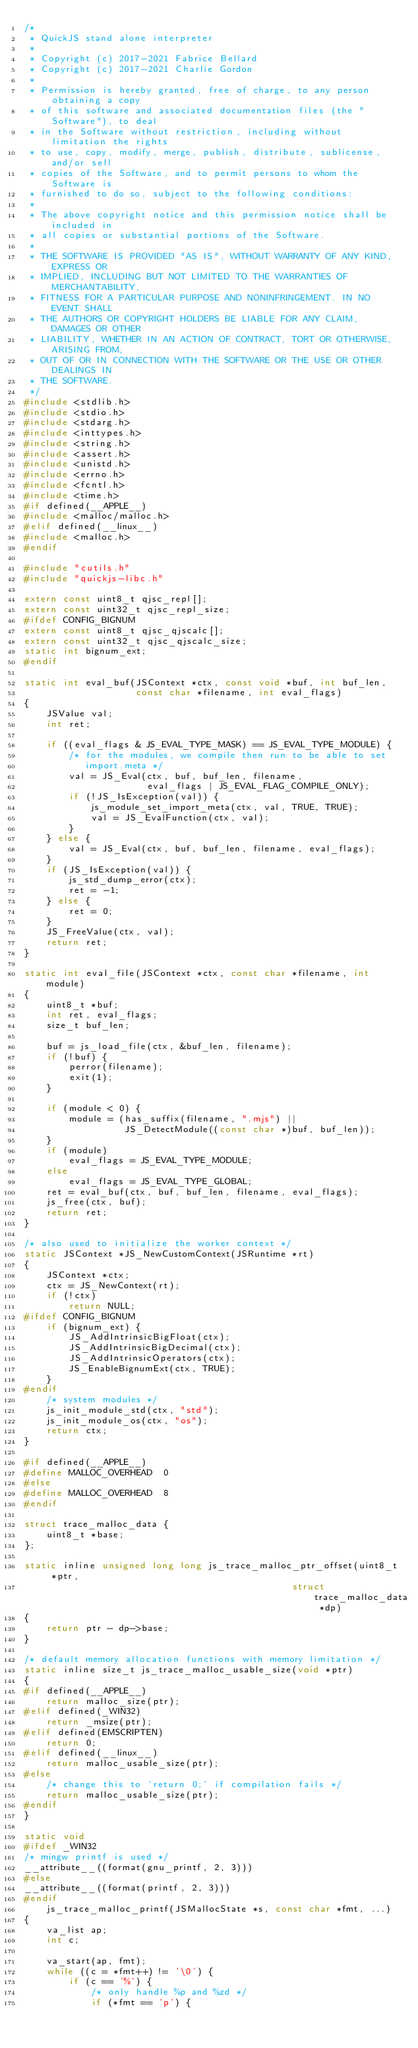Convert code to text. <code><loc_0><loc_0><loc_500><loc_500><_C_>/*
 * QuickJS stand alone interpreter
 * 
 * Copyright (c) 2017-2021 Fabrice Bellard
 * Copyright (c) 2017-2021 Charlie Gordon
 *
 * Permission is hereby granted, free of charge, to any person obtaining a copy
 * of this software and associated documentation files (the "Software"), to deal
 * in the Software without restriction, including without limitation the rights
 * to use, copy, modify, merge, publish, distribute, sublicense, and/or sell
 * copies of the Software, and to permit persons to whom the Software is
 * furnished to do so, subject to the following conditions:
 *
 * The above copyright notice and this permission notice shall be included in
 * all copies or substantial portions of the Software.
 *
 * THE SOFTWARE IS PROVIDED "AS IS", WITHOUT WARRANTY OF ANY KIND, EXPRESS OR
 * IMPLIED, INCLUDING BUT NOT LIMITED TO THE WARRANTIES OF MERCHANTABILITY,
 * FITNESS FOR A PARTICULAR PURPOSE AND NONINFRINGEMENT. IN NO EVENT SHALL
 * THE AUTHORS OR COPYRIGHT HOLDERS BE LIABLE FOR ANY CLAIM, DAMAGES OR OTHER
 * LIABILITY, WHETHER IN AN ACTION OF CONTRACT, TORT OR OTHERWISE, ARISING FROM,
 * OUT OF OR IN CONNECTION WITH THE SOFTWARE OR THE USE OR OTHER DEALINGS IN
 * THE SOFTWARE.
 */
#include <stdlib.h>
#include <stdio.h>
#include <stdarg.h>
#include <inttypes.h>
#include <string.h>
#include <assert.h>
#include <unistd.h>
#include <errno.h>
#include <fcntl.h>
#include <time.h>
#if defined(__APPLE__)
#include <malloc/malloc.h>
#elif defined(__linux__)
#include <malloc.h>
#endif

#include "cutils.h"
#include "quickjs-libc.h"

extern const uint8_t qjsc_repl[];
extern const uint32_t qjsc_repl_size;
#ifdef CONFIG_BIGNUM
extern const uint8_t qjsc_qjscalc[];
extern const uint32_t qjsc_qjscalc_size;
static int bignum_ext;
#endif

static int eval_buf(JSContext *ctx, const void *buf, int buf_len,
                    const char *filename, int eval_flags)
{
    JSValue val;
    int ret;

    if ((eval_flags & JS_EVAL_TYPE_MASK) == JS_EVAL_TYPE_MODULE) {
        /* for the modules, we compile then run to be able to set
           import.meta */
        val = JS_Eval(ctx, buf, buf_len, filename,
                      eval_flags | JS_EVAL_FLAG_COMPILE_ONLY);
        if (!JS_IsException(val)) {
            js_module_set_import_meta(ctx, val, TRUE, TRUE);
            val = JS_EvalFunction(ctx, val);
        }
    } else {
        val = JS_Eval(ctx, buf, buf_len, filename, eval_flags);
    }
    if (JS_IsException(val)) {
        js_std_dump_error(ctx);
        ret = -1;
    } else {
        ret = 0;
    }
    JS_FreeValue(ctx, val);
    return ret;
}

static int eval_file(JSContext *ctx, const char *filename, int module)
{
    uint8_t *buf;
    int ret, eval_flags;
    size_t buf_len;
    
    buf = js_load_file(ctx, &buf_len, filename);
    if (!buf) {
        perror(filename);
        exit(1);
    }

    if (module < 0) {
        module = (has_suffix(filename, ".mjs") ||
                  JS_DetectModule((const char *)buf, buf_len));
    }
    if (module)
        eval_flags = JS_EVAL_TYPE_MODULE;
    else
        eval_flags = JS_EVAL_TYPE_GLOBAL;
    ret = eval_buf(ctx, buf, buf_len, filename, eval_flags);
    js_free(ctx, buf);
    return ret;
}

/* also used to initialize the worker context */
static JSContext *JS_NewCustomContext(JSRuntime *rt)
{
    JSContext *ctx;
    ctx = JS_NewContext(rt);
    if (!ctx)
        return NULL;
#ifdef CONFIG_BIGNUM
    if (bignum_ext) {
        JS_AddIntrinsicBigFloat(ctx);
        JS_AddIntrinsicBigDecimal(ctx);
        JS_AddIntrinsicOperators(ctx);
        JS_EnableBignumExt(ctx, TRUE);
    }
#endif
    /* system modules */
    js_init_module_std(ctx, "std");
    js_init_module_os(ctx, "os");
    return ctx;
}

#if defined(__APPLE__)
#define MALLOC_OVERHEAD  0
#else
#define MALLOC_OVERHEAD  8
#endif

struct trace_malloc_data {
    uint8_t *base;
};

static inline unsigned long long js_trace_malloc_ptr_offset(uint8_t *ptr,
                                                struct trace_malloc_data *dp)
{
    return ptr - dp->base;
}

/* default memory allocation functions with memory limitation */
static inline size_t js_trace_malloc_usable_size(void *ptr)
{
#if defined(__APPLE__)
    return malloc_size(ptr);
#elif defined(_WIN32)
    return _msize(ptr);
#elif defined(EMSCRIPTEN)
    return 0;
#elif defined(__linux__)
    return malloc_usable_size(ptr);
#else
    /* change this to `return 0;` if compilation fails */
    return malloc_usable_size(ptr);
#endif
}

static void
#ifdef _WIN32
/* mingw printf is used */
__attribute__((format(gnu_printf, 2, 3)))
#else
__attribute__((format(printf, 2, 3)))
#endif
    js_trace_malloc_printf(JSMallocState *s, const char *fmt, ...)
{
    va_list ap;
    int c;

    va_start(ap, fmt);
    while ((c = *fmt++) != '\0') {
        if (c == '%') {
            /* only handle %p and %zd */
            if (*fmt == 'p') {</code> 